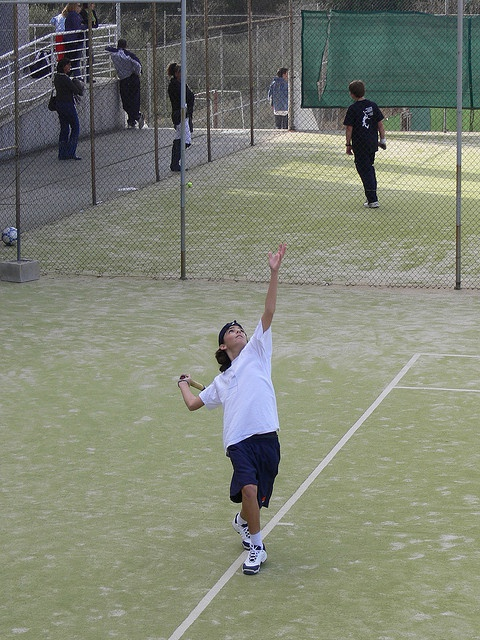Describe the objects in this image and their specific colors. I can see people in gray, lavender, black, and darkgray tones, people in gray, black, and darkgray tones, people in gray and black tones, people in gray, black, darkgray, and navy tones, and people in gray, black, and navy tones in this image. 